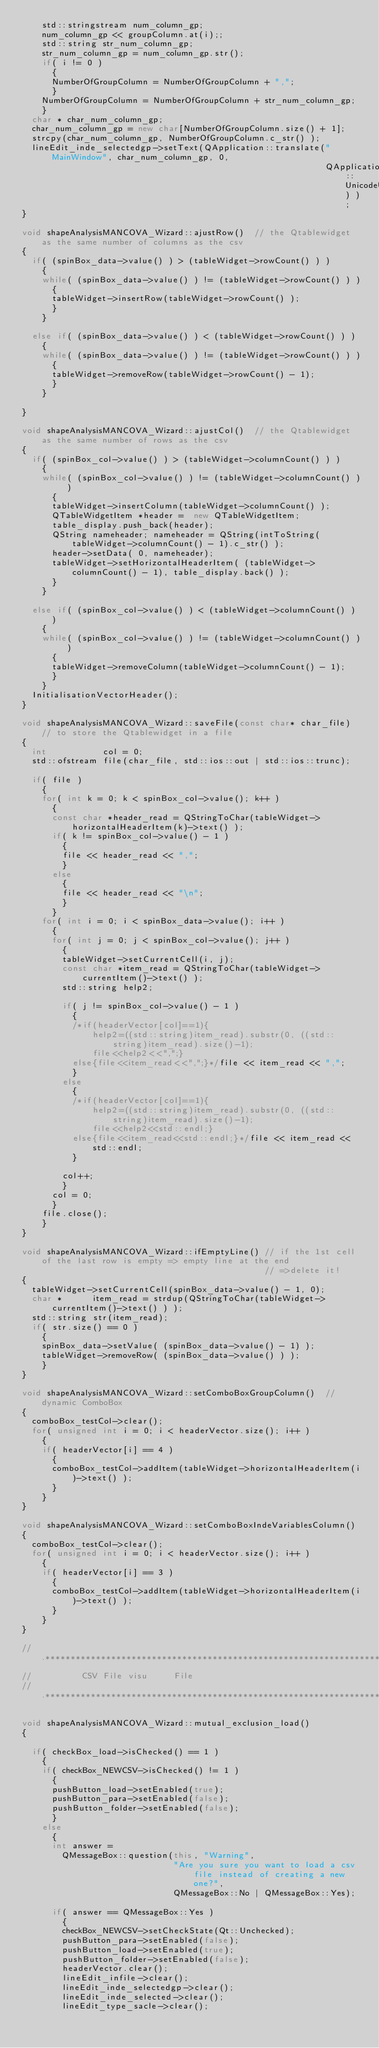Convert code to text. <code><loc_0><loc_0><loc_500><loc_500><_C++_>    std::stringstream num_column_gp;
    num_column_gp << groupColumn.at(i);;
    std::string str_num_column_gp;
    str_num_column_gp = num_column_gp.str();
    if( i != 0 )
      {
      NumberOfGroupColumn = NumberOfGroupColumn + ",";
      }
    NumberOfGroupColumn = NumberOfGroupColumn + str_num_column_gp;
    }
  char * char_num_column_gp;
  char_num_column_gp = new char[NumberOfGroupColumn.size() + 1];
  strcpy(char_num_column_gp, NumberOfGroupColumn.c_str() );
  lineEdit_inde_selectedgp->setText(QApplication::translate("MainWindow", char_num_column_gp, 0,
                                                            QApplication::UnicodeUTF8) );
}

void shapeAnalysisMANCOVA_Wizard::ajustRow()  // the Qtablewidget as the same number of columns as the csv
{
  if( (spinBox_data->value() ) > (tableWidget->rowCount() ) )
    {
    while( (spinBox_data->value() ) != (tableWidget->rowCount() ) )
      {
      tableWidget->insertRow(tableWidget->rowCount() );
      }
    }

  else if( (spinBox_data->value() ) < (tableWidget->rowCount() ) )
    {
    while( (spinBox_data->value() ) != (tableWidget->rowCount() ) )
      {
      tableWidget->removeRow(tableWidget->rowCount() - 1);
      }
    }

}

void shapeAnalysisMANCOVA_Wizard::ajustCol()  // the Qtablewidget as the same number of rows as the csv
{
  if( (spinBox_col->value() ) > (tableWidget->columnCount() ) )
    {
    while( (spinBox_col->value() ) != (tableWidget->columnCount() ) )
      {
      tableWidget->insertColumn(tableWidget->columnCount() );
      QTableWidgetItem *header =  new QTableWidgetItem;
      table_display.push_back(header);
      QString nameheader; nameheader = QString(intToString(tableWidget->columnCount() - 1).c_str() );
      header->setData( 0, nameheader);
      tableWidget->setHorizontalHeaderItem( (tableWidget->columnCount() - 1), table_display.back() );
      }
    }

  else if( (spinBox_col->value() ) < (tableWidget->columnCount() ) )
    {
    while( (spinBox_col->value() ) != (tableWidget->columnCount() ) )
      {
      tableWidget->removeColumn(tableWidget->columnCount() - 1);
      }
    }
  InitialisationVectorHeader();
}

void shapeAnalysisMANCOVA_Wizard::saveFile(const char* char_file)  // to store the Qtablewidget in a file
{
  int           col = 0;
  std::ofstream file(char_file, std::ios::out | std::ios::trunc);

  if( file )
    {
    for( int k = 0; k < spinBox_col->value(); k++ )
      {
      const char *header_read = QStringToChar(tableWidget->horizontalHeaderItem(k)->text() );
      if( k != spinBox_col->value() - 1 )
        {
        file << header_read << ",";
        }
      else
        {
        file << header_read << "\n";
        }
      }
    for( int i = 0; i < spinBox_data->value(); i++ )
      {
      for( int j = 0; j < spinBox_col->value(); j++ )
        {
        tableWidget->setCurrentCell(i, j);
        const char *item_read = QStringToChar(tableWidget->currentItem()->text() );
        std::string help2;

        if( j != spinBox_col->value() - 1 )
          {
          /*if(headerVector[col]==1){
              help2=((std::string)item_read).substr(0, ((std::string)item_read).size()-1);
              file<<help2<<",";}
          else{file<<item_read<<",";}*/file << item_read << ",";
          }
        else
          {
          /*if(headerVector[col]==1){
              help2=((std::string)item_read).substr(0, ((std::string)item_read).size()-1);
              file<<help2<<std::endl;}
          else{file<<item_read<<std::endl;}*/file << item_read << std::endl;
          }

        col++;
        }
      col = 0;
      }
    file.close();
    }
}

void shapeAnalysisMANCOVA_Wizard::ifEmptyLine() // if the 1st cell of the last row is empty => empty line at the end
                                                // =>delete it!
{
  tableWidget->setCurrentCell(spinBox_data->value() - 1, 0);
  char *      item_read = strdup(QStringToChar(tableWidget->currentItem()->text() ) );
  std::string str(item_read);
  if( str.size() == 0 )
    {
    spinBox_data->setValue( (spinBox_data->value() - 1) );
    tableWidget->removeRow( (spinBox_data->value() ) );
    }
}

void shapeAnalysisMANCOVA_Wizard::setComboBoxGroupColumn()  // dynamic ComboBox
{
  comboBox_testCol->clear();
  for( unsigned int i = 0; i < headerVector.size(); i++ )
    {
    if( headerVector[i] == 4 )
      {
      comboBox_testCol->addItem(tableWidget->horizontalHeaderItem(i)->text() );
      }
    }
}

void shapeAnalysisMANCOVA_Wizard::setComboBoxIndeVariablesColumn()
{
  comboBox_testCol->clear();
  for( unsigned int i = 0; i < headerVector.size(); i++ )
    {
    if( headerVector[i] == 3 )
      {
      comboBox_testCol->addItem(tableWidget->horizontalHeaderItem(i)->text() );
      }
    }
}

// .*******************************************************************************
//          CSV File visu     File
// .*******************************************************************************

void shapeAnalysisMANCOVA_Wizard::mutual_exclusion_load()
{

  if( checkBox_load->isChecked() == 1 )
    {
    if( checkBox_NEWCSV->isChecked() != 1 )
      {
      pushButton_load->setEnabled(true);
      pushButton_para->setEnabled(false);
      pushButton_folder->setEnabled(false);
      }
    else
      {
      int answer =
        QMessageBox::question(this, "Warning",
                              "Are you sure you want to load a csv file instead of creating a new one?",
                              QMessageBox::No | QMessageBox::Yes);

      if( answer == QMessageBox::Yes )
        {
        checkBox_NEWCSV->setCheckState(Qt::Unchecked);
        pushButton_para->setEnabled(false);
        pushButton_load->setEnabled(true);
        pushButton_folder->setEnabled(false);
        headerVector.clear();
        lineEdit_infile->clear();
        lineEdit_inde_selectedgp->clear();
        lineEdit_inde_selected->clear();
        lineEdit_type_sacle->clear();</code> 